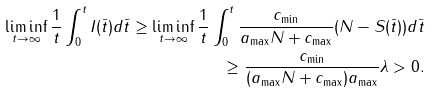<formula> <loc_0><loc_0><loc_500><loc_500>\liminf _ { t \to \infty } \frac { 1 } { t } \int _ { 0 } ^ { t } I ( \bar { t } ) d \bar { t } \geq \liminf _ { t \to \infty } \frac { 1 } { t } \int _ { 0 } ^ { t } \frac { c _ { \min } } { a _ { \max } N + c _ { \max } } ( N - S ( \bar { t } ) ) d \bar { t } \\ \geq \frac { c _ { \min } } { ( a _ { \max } N + c _ { \max } ) a _ { \max } } \lambda > 0 .</formula> 